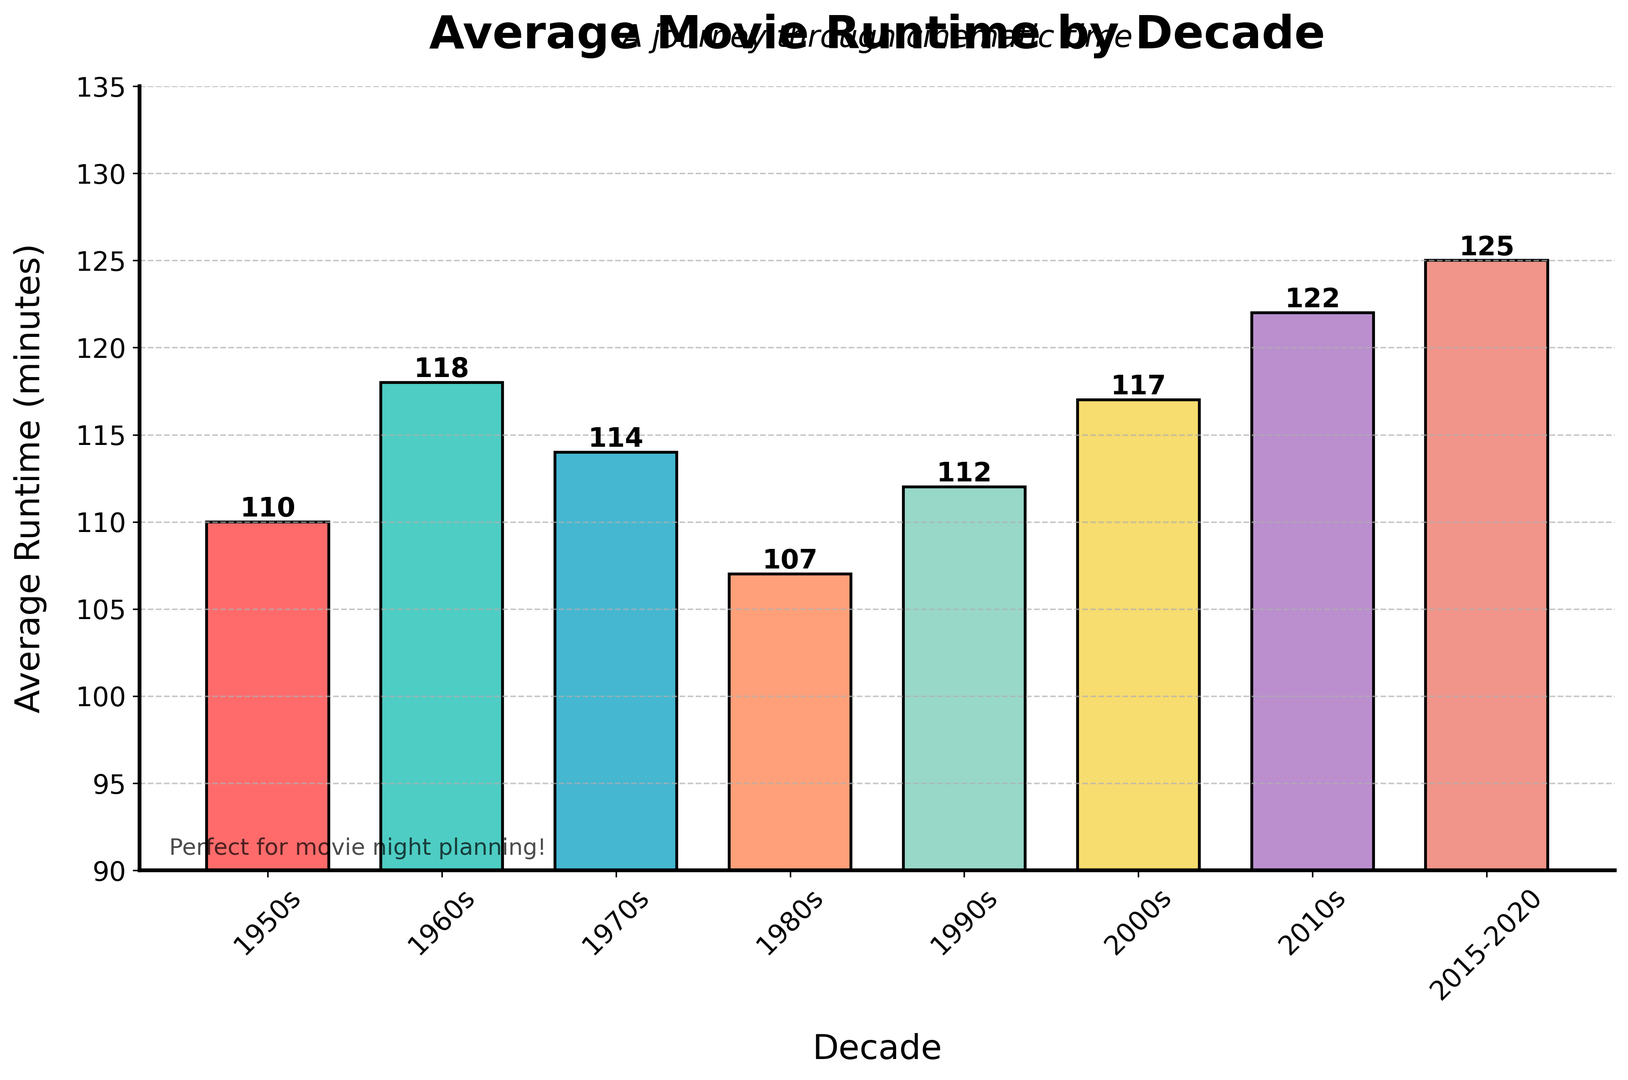What decade has the shortest average runtime? By looking at the height of the bars, the shortest bar represents the decade with the shortest average runtime. The 1980s bar is the shortest showing 107 minutes.
Answer: 1980s Which decade has the longest average runtime? By comparing the heights of the bars, the tallest bar identifies the decade with the longest average runtime. The 2015-2020 bar is the tallest, showing 125 minutes.
Answer: 2015-2020 How much longer is the average runtime of movies in the 2010s compared to the 1980s? Subtract the average runtime of the 1980s from that of the 2010s: 122 - 107 = 15 minutes.
Answer: 15 minutes What is the average runtime of movies in the 1960s? Look at the bar labeled "1960s" and read the value at the top. This bar shows an average runtime of 118 minutes.
Answer: 118 minutes By how much did the average runtime increase from the 2000s to the 2010s? Subtract the average runtime in the 2000s from the runtime in the 2010s: 122 - 117 = 5 minutes.
Answer: 5 minutes Which decades have average runtimes greater than 115 minutes? Identify bars with heights greater than 115. The bars for the 1960s (118 minutes), 2000s (117 minutes), 2010s (122 minutes), and 2015-2020 (125 minutes) meet this criterion.
Answer: 1960s, 2000s, 2010s, 2015-2020 By how much longer is the average runtime in the 2015-2020 period compared to the 1950s? Subtract the average runtime of the 1950s from that of 2015-2020: 125 - 110 = 15 minutes.
Answer: 15 minutes What is the increase in average runtime from the 1970s to the 2010s? Subtract the average runtime in the 1970s from the runtime in the 2010s: 122 - 114 = 8 minutes.
Answer: 8 minutes 